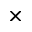Convert formula to latex. <formula><loc_0><loc_0><loc_500><loc_500>\times</formula> 